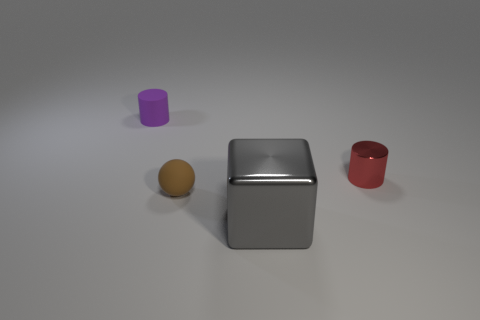There is a small red cylinder that is right of the small matte thing that is right of the purple cylinder; is there a tiny sphere that is on the right side of it?
Ensure brevity in your answer.  No. Are any big metal objects visible?
Give a very brief answer. Yes. Is the number of purple matte cylinders to the right of the large gray metal thing greater than the number of tiny matte balls to the right of the red object?
Your response must be concise. No. What size is the brown thing that is the same material as the tiny purple cylinder?
Keep it short and to the point. Small. There is a metal object to the right of the shiny thing in front of the small object that is to the right of the brown thing; what size is it?
Give a very brief answer. Small. There is a rubber thing to the right of the tiny purple rubber cylinder; what is its color?
Provide a succinct answer. Brown. Is the number of spheres left of the tiny matte sphere greater than the number of big metallic cylinders?
Provide a succinct answer. No. Does the small rubber object to the right of the small purple cylinder have the same shape as the small purple object?
Your response must be concise. No. What number of yellow things are either big blocks or cylinders?
Your answer should be compact. 0. Is the number of red matte cylinders greater than the number of red things?
Provide a short and direct response. No. 